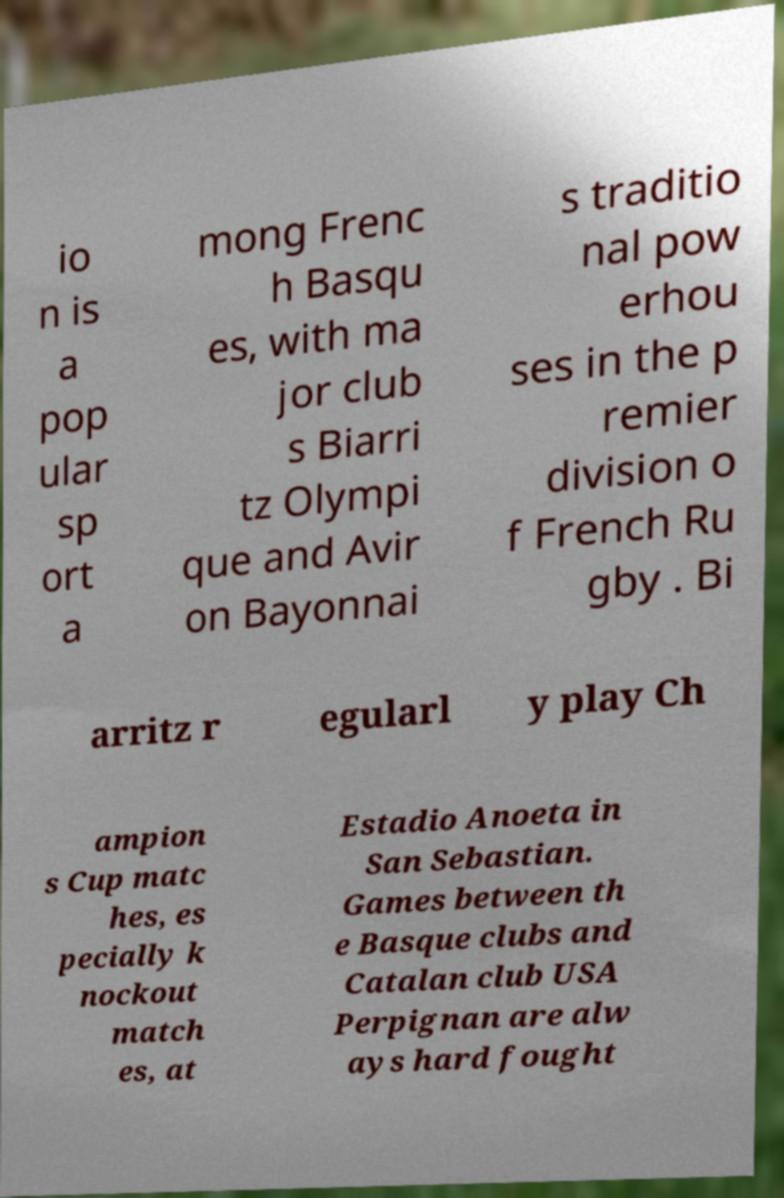I need the written content from this picture converted into text. Can you do that? io n is a pop ular sp ort a mong Frenc h Basqu es, with ma jor club s Biarri tz Olympi que and Avir on Bayonnai s traditio nal pow erhou ses in the p remier division o f French Ru gby . Bi arritz r egularl y play Ch ampion s Cup matc hes, es pecially k nockout match es, at Estadio Anoeta in San Sebastian. Games between th e Basque clubs and Catalan club USA Perpignan are alw ays hard fought 